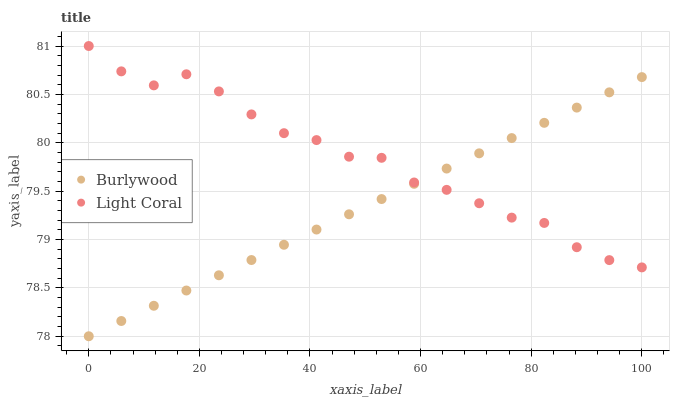Does Burlywood have the minimum area under the curve?
Answer yes or no. Yes. Does Light Coral have the maximum area under the curve?
Answer yes or no. Yes. Does Light Coral have the minimum area under the curve?
Answer yes or no. No. Is Burlywood the smoothest?
Answer yes or no. Yes. Is Light Coral the roughest?
Answer yes or no. Yes. Is Light Coral the smoothest?
Answer yes or no. No. Does Burlywood have the lowest value?
Answer yes or no. Yes. Does Light Coral have the lowest value?
Answer yes or no. No. Does Light Coral have the highest value?
Answer yes or no. Yes. Does Burlywood intersect Light Coral?
Answer yes or no. Yes. Is Burlywood less than Light Coral?
Answer yes or no. No. Is Burlywood greater than Light Coral?
Answer yes or no. No. 